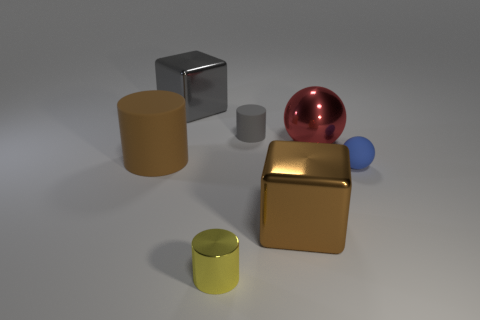How big is the shiny object that is both to the left of the small gray cylinder and in front of the large rubber cylinder?
Your answer should be very brief. Small. Do the blue object and the big red thing have the same shape?
Make the answer very short. Yes. What is the shape of the blue thing that is the same material as the brown cylinder?
Make the answer very short. Sphere. What number of small objects are either balls or brown shiny blocks?
Make the answer very short. 1. There is a metal block that is on the left side of the yellow metal cylinder; is there a gray block that is to the left of it?
Give a very brief answer. No. Are there any large metallic objects?
Provide a succinct answer. Yes. There is a large cube behind the brown rubber cylinder behind the yellow cylinder; what color is it?
Your response must be concise. Gray. What material is the large brown object that is the same shape as the large gray shiny object?
Ensure brevity in your answer.  Metal. What number of brown cubes have the same size as the gray metallic object?
Offer a terse response. 1. What is the size of the brown cylinder that is made of the same material as the small sphere?
Provide a short and direct response. Large. 